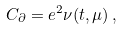Convert formula to latex. <formula><loc_0><loc_0><loc_500><loc_500>C _ { \partial } = e ^ { 2 } \nu ( t , \mu ) \, ,</formula> 